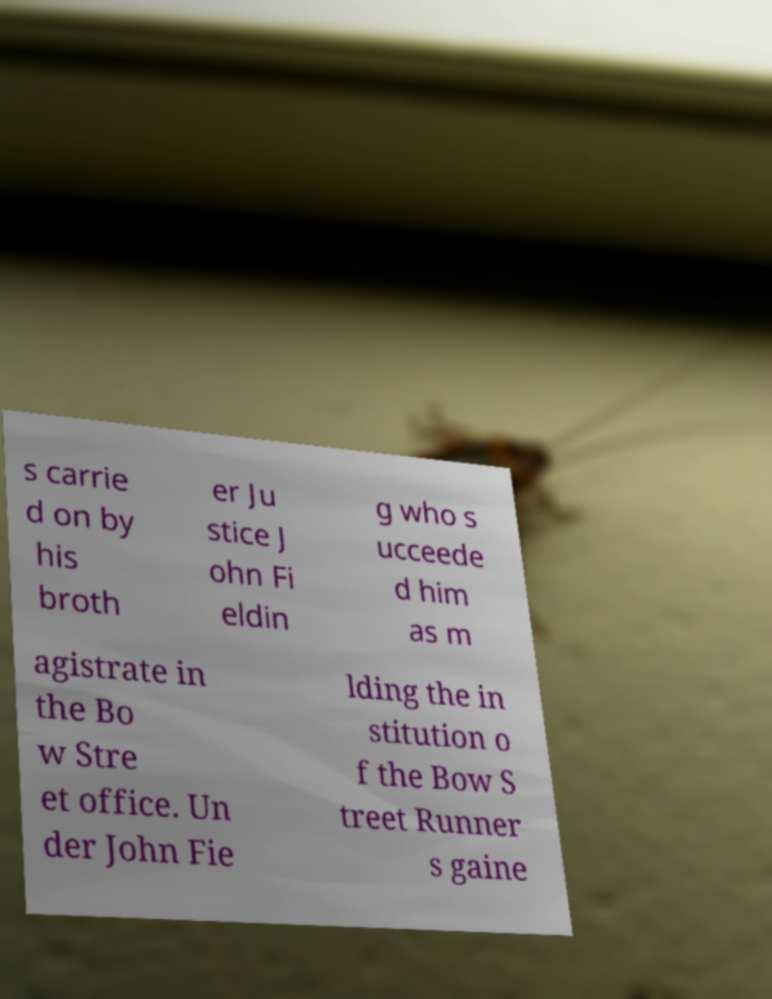What messages or text are displayed in this image? I need them in a readable, typed format. s carrie d on by his broth er Ju stice J ohn Fi eldin g who s ucceede d him as m agistrate in the Bo w Stre et office. Un der John Fie lding the in stitution o f the Bow S treet Runner s gaine 